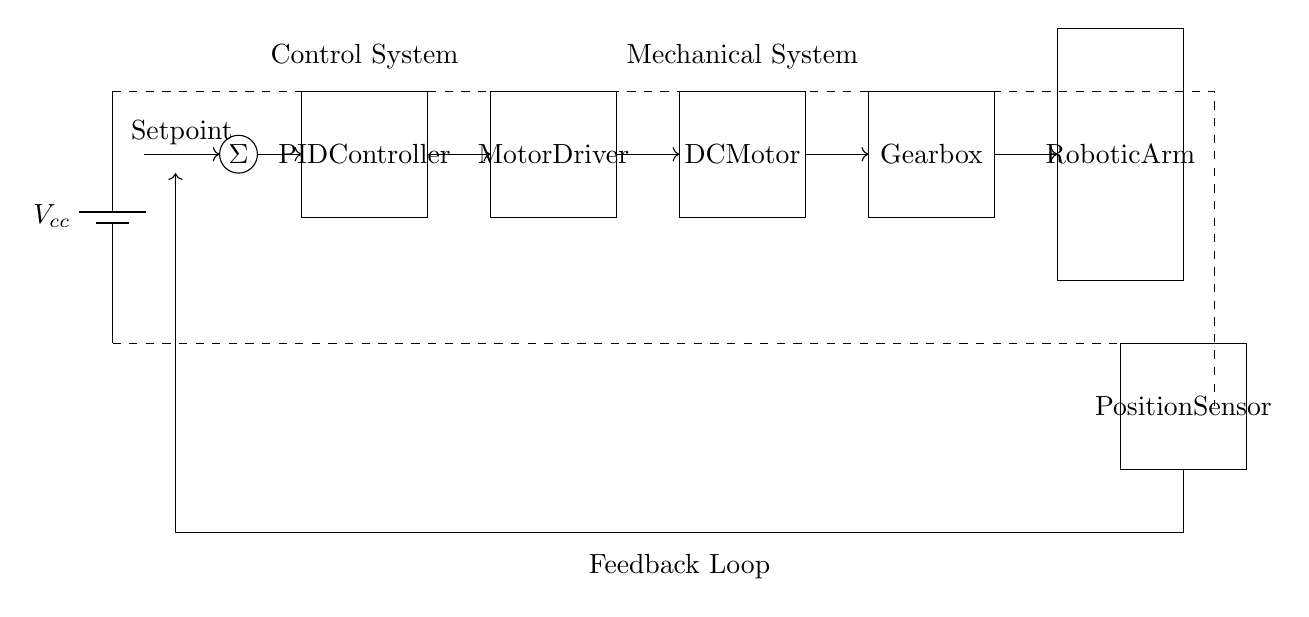What is the main controlling element in this circuit? The PID Controller is the central component that calculates the control signal based on the setpoint and feedback. It adjusts the motor driver to help achieve the desired position.
Answer: PID Controller What is the function of the feedback loop in this circuit? The feedback loop takes the position measurement from the position sensor and sends it back to the summing junction to compare it with the setpoint, allowing for corrections and precise control of the robotic arm's position.
Answer: Correction Which component receives the output from the PID Controller? The Motor Driver receives the output from the PID Controller and translates it into appropriate signals to control the DC Motor.
Answer: Motor Driver What type of motor is used in this circuit? A DC Motor is specified as the actuator to provide motion to the robotic arm.
Answer: DC Motor What component is responsible for sensing the position of the robotic arm? The Position Sensor is tasked with detecting the current position of the robotic arm and providing feedback for control purposes.
Answer: Position Sensor What is the power source for the entire circuit? The circuit is powered by a battery, noted as Vcc, which supplies voltage to all components.
Answer: Battery How many stages are there in the motor control path? There are four main stages: the PID Controller, Motor Driver, DC Motor, and Gearbox. These stages work sequentially to achieve the control of the robotic arm.
Answer: Four 